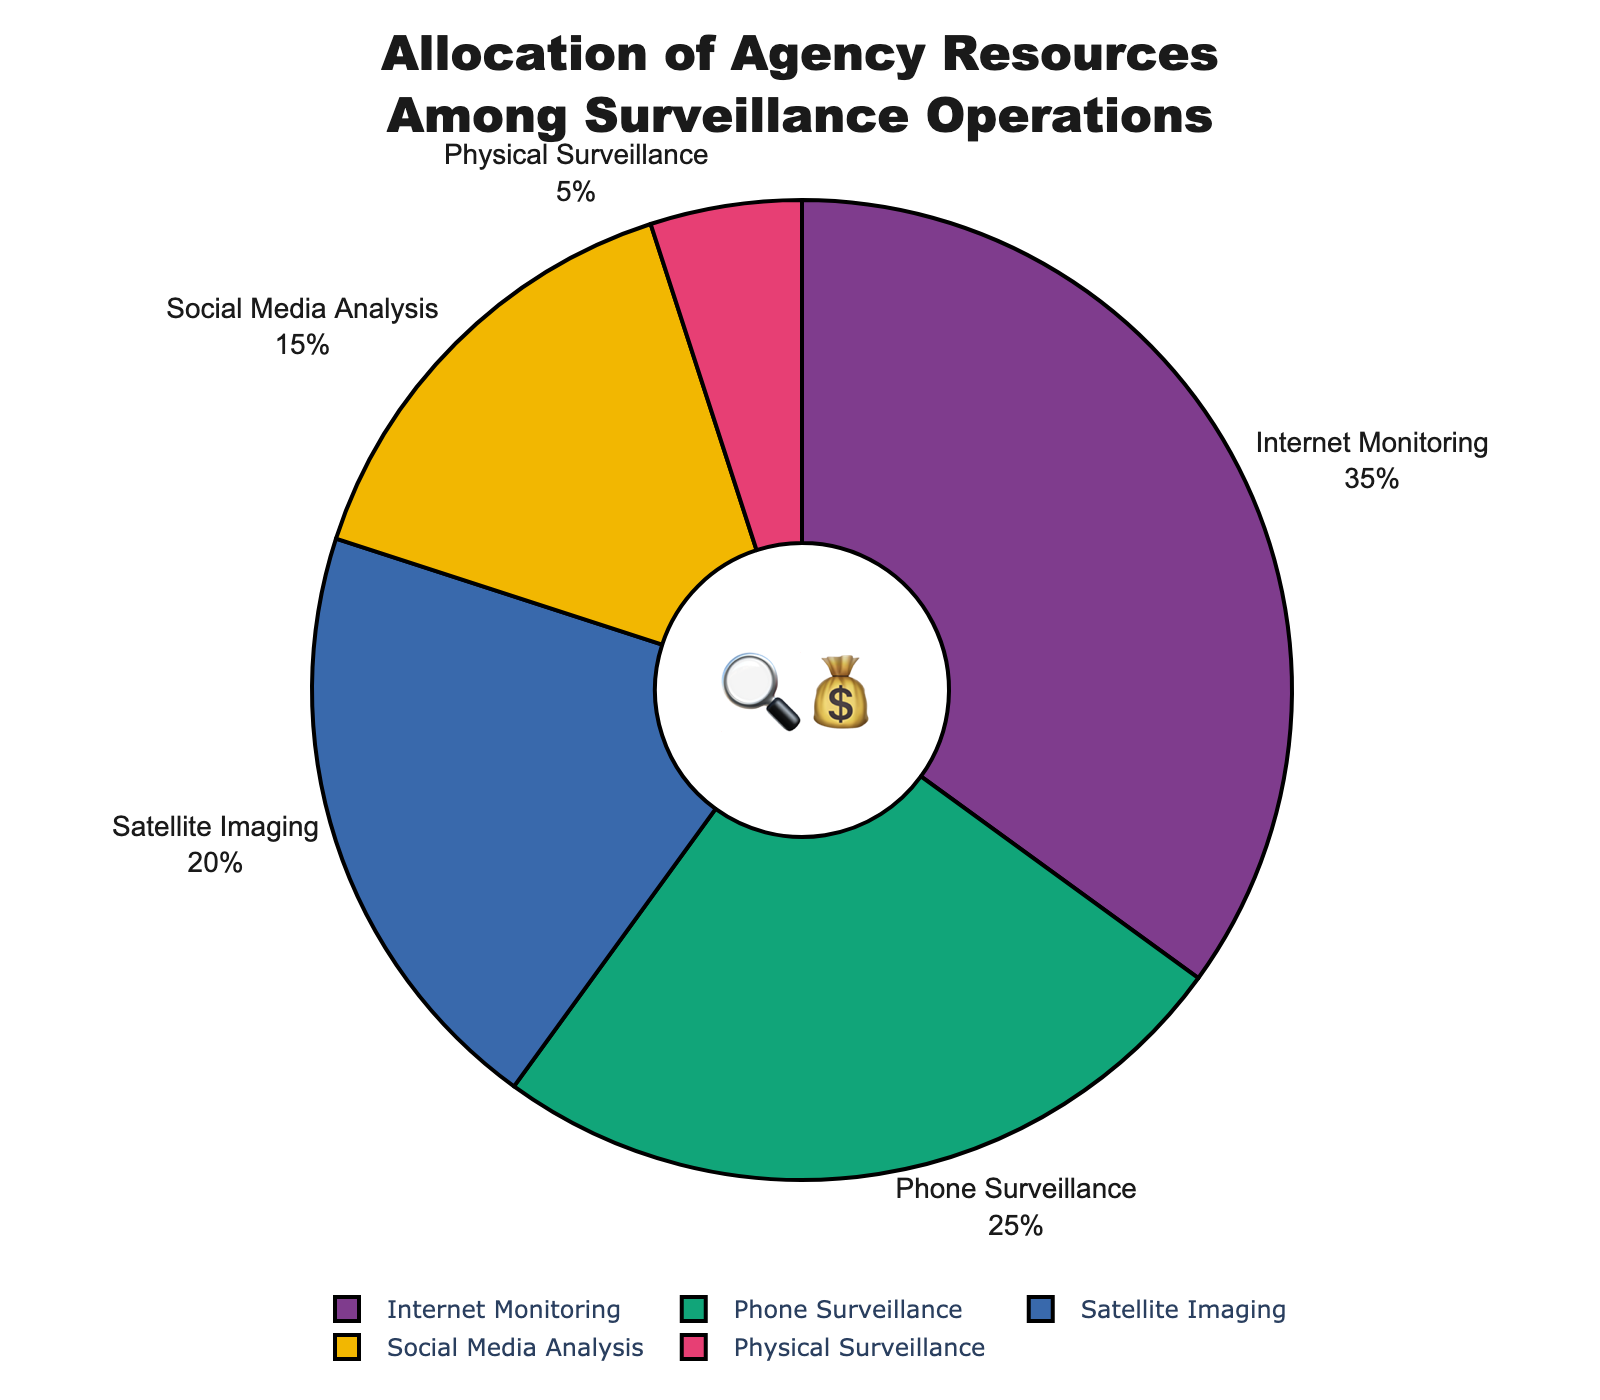What's the title of the figure? The title is usually placed at the top of the chart; in this case, it says, "Allocation of Agency Resources Among Surveillance Operations."
Answer: Allocation of Agency Resources Among Surveillance Operations What percentage of the budget is allocated to Internet Monitoring? Look at the wedge labeled "Internet Monitoring" and read the percentage next to it.
Answer: 35% Which surveillance operation receives the smallest portion of the budget? Check each wedge's label and its corresponding percentage, find the smallest one.
Answer: Physical Surveillance How much more budget is allocated to Internet Monitoring compared to Social Media Analysis? Subtract the budget percentage for Social Media Analysis from that for Internet Monitoring (35% - 15%).
Answer: 20% What operations together make up more than half of the budget allocation? Calculate cumulative percentages until they exceed 50%. Internet Monitoring (35%) + Phone Surveillance (25%) = 60%.
Answer: Internet Monitoring and Phone Surveillance Besides the title, what other text can be found in the center of the chart? Check the chart's annotations; there is an emoji text in the center of the pie chart.
Answer: 🔍💰 What operations have emoji associated with technology? Identify emojis that represent technological devices and find their corresponding operations.
Answer: Internet Monitoring (🖥️), Phone Surveillance (📱), Satellite Imaging (🛰️) Rank the surveillance operations from highest to lowest budget allocation. Arrange the operations by their percentages in descending order.
Answer: Internet Monitoring, Phone Surveillance, Satellite Imaging, Social Media Analysis, Physical Surveillance What is the combined budget allocation for Satellite Imaging and Physical Surveillance? Add the percentages for Satellite Imaging and Physical Surveillance (20% + 5%).
Answer: 25% Which operation has an allocation close to a quarter of the budget? Identify the operation with a budget allocation near 25%.
Answer: Phone Surveillance 